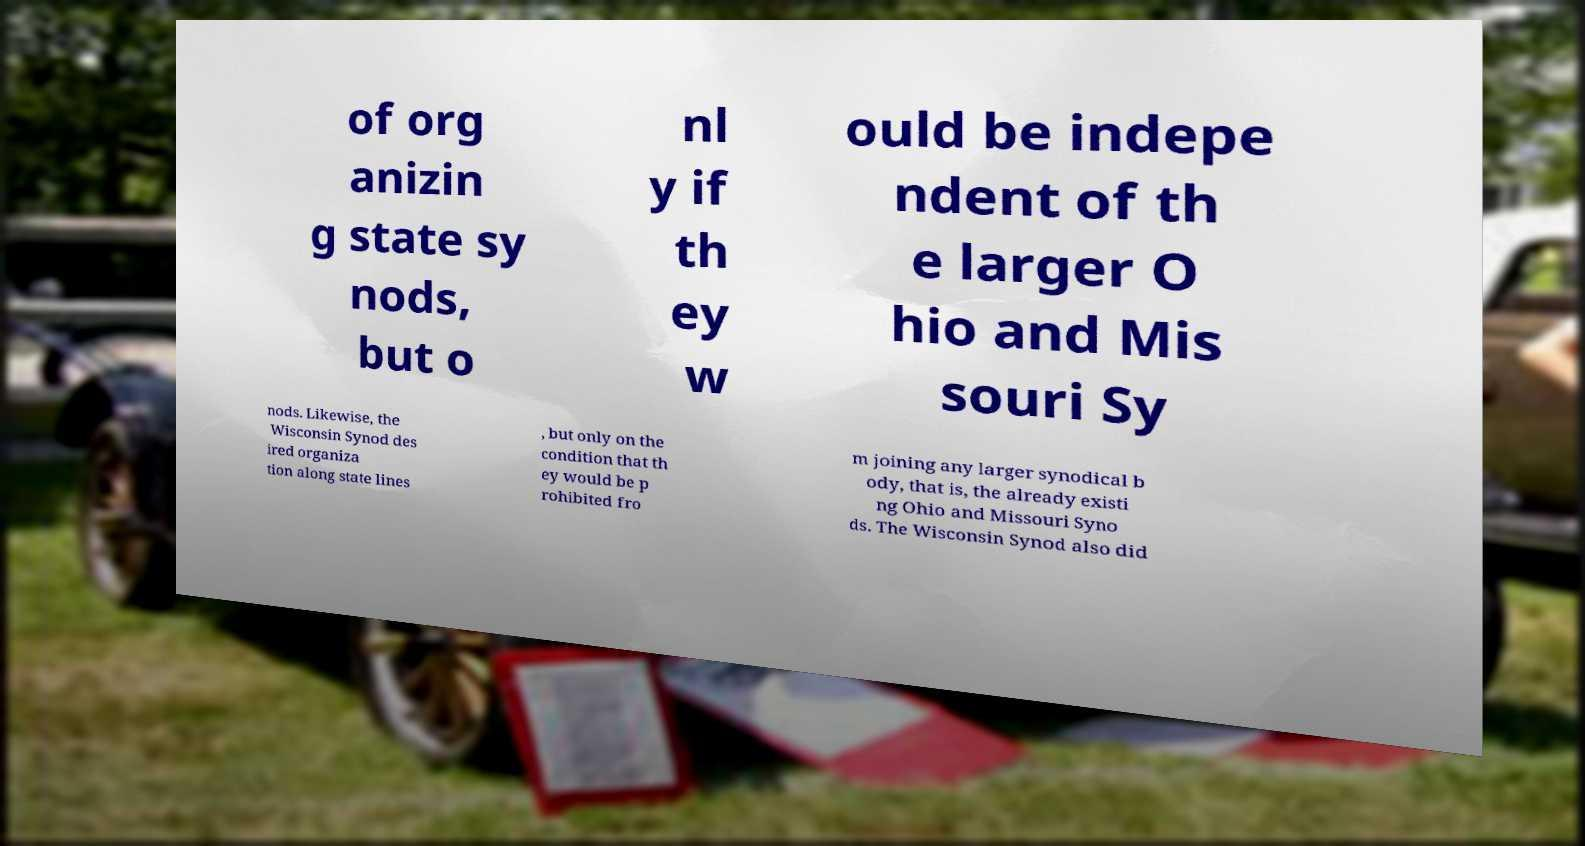Could you assist in decoding the text presented in this image and type it out clearly? of org anizin g state sy nods, but o nl y if th ey w ould be indepe ndent of th e larger O hio and Mis souri Sy nods. Likewise, the Wisconsin Synod des ired organiza tion along state lines , but only on the condition that th ey would be p rohibited fro m joining any larger synodical b ody, that is, the already existi ng Ohio and Missouri Syno ds. The Wisconsin Synod also did 